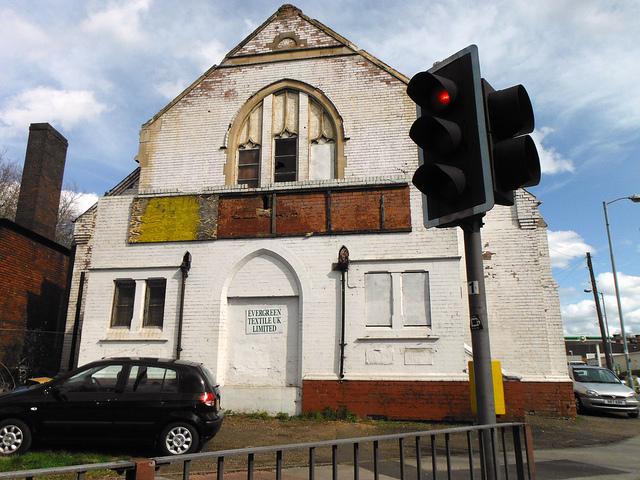Is it daytime?
Short answer required. Yes. Is the light on red or green?
Be succinct. Red. What time of day is this?
Answer briefly. Midday. What is the object on top of the post?
Keep it brief. Traffic light. What style of architecture does the building exemplify?
Give a very brief answer. Old. Are there clouds in the sky?
Write a very short answer. Yes. 